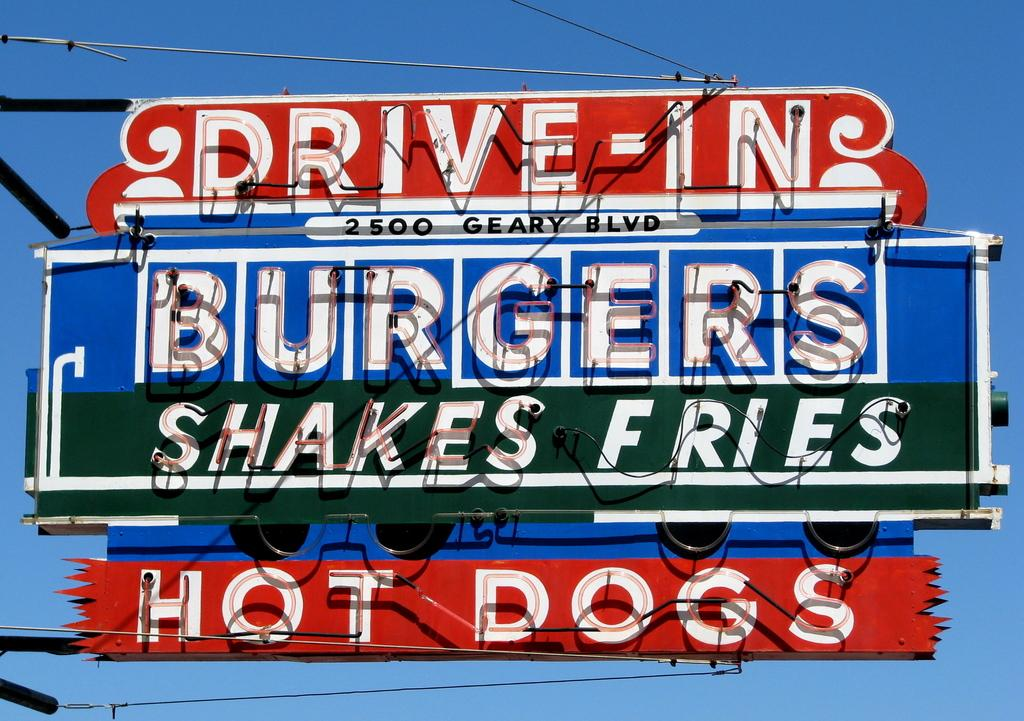Provide a one-sentence caption for the provided image. A sign that advertises a Drive In that served Burgers, shakes, and fries. 